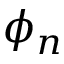Convert formula to latex. <formula><loc_0><loc_0><loc_500><loc_500>\phi _ { n }</formula> 